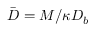<formula> <loc_0><loc_0><loc_500><loc_500>\bar { D } = M / \kappa D _ { b }</formula> 